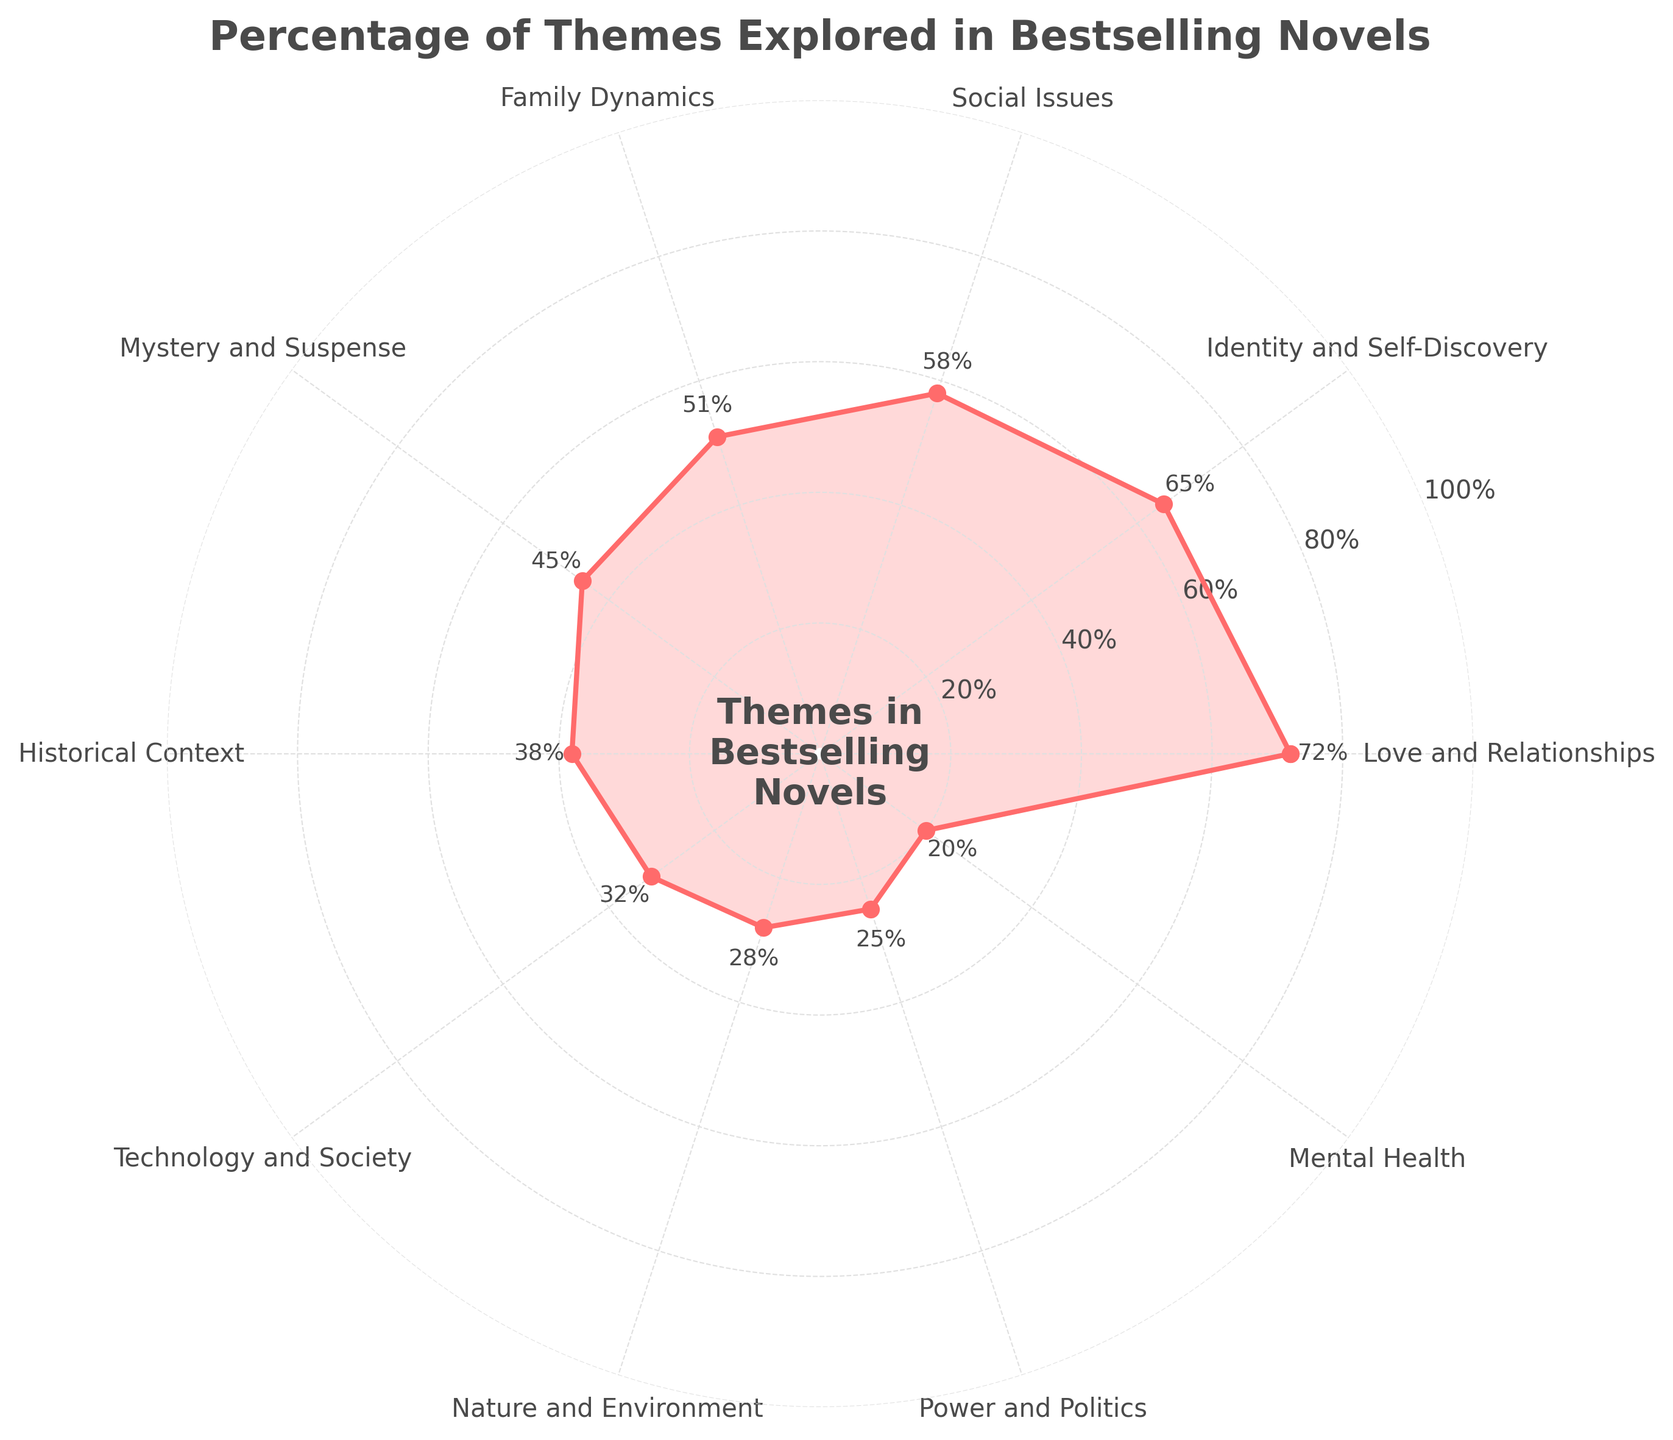What is the title of the plot? The title is located at the top center of the plot. It reads "Percentage of Themes Explored in Bestselling Novels".
Answer: Percentage of Themes Explored in Bestselling Novels Which theme has the highest percentage? The theme with the highest percentage can be identified by the highest point on the plot, which is "Love and Relationships" at 72%.
Answer: Love and Relationships What is the percentage value of the theme "Power and Politics"? Locate "Power and Politics" on the plot and read the percentage value next to it, which is 25%.
Answer: 25% What is the difference in percentage between "Love and Relationships" and "Social Issues"? "Love and Relationships" is at 72% and "Social Issues" is at 58%. The difference is calculated as 72% - 58% = 14%.
Answer: 14% Which themes have a percentage greater than 50%? The themes above the 50% mark on the plot are "Love and Relationships" (72%), "Identity and Self-Discovery" (65%), and "Social Issues" (58%).
Answer: Love and Relationships, Identity and Self-Discovery, Social Issues How many themes are included in the plot? Count the number of distinct data points or labels around the plot. There are 10 themes represented.
Answer: 10 Is the "Technology and Society" theme more prominent than "Mental Health"? Compare the percentages for "Technology and Society" (32%) and "Mental Health" (20%). "Technology and Society" has a higher percentage.
Answer: Yes What is the average percentage of themes that explore family dynamics and historical context? The percentages for "Family Dynamics" and "Historical Context" are 51% and 38%, respectively. Their average is (51 + 38) / 2 = 44.5%.
Answer: 44.5% List the themes that have a percentage less than 40%. The themes below 40% on the plot are "Historical Context" (38%), "Technology and Society" (32%), "Nature and Environment" (28%), "Power and Politics" (25%), and "Mental Health" (20%).
Answer: Historical Context, Technology and Society, Nature and Environment, Power and Politics, Mental Health How is percentage data visually represented on this plot? Percentage data is shown as points on a circular plot, connected by lines, and the area under the curve is filled.
Answer: Circular plot with connected points and filled area 